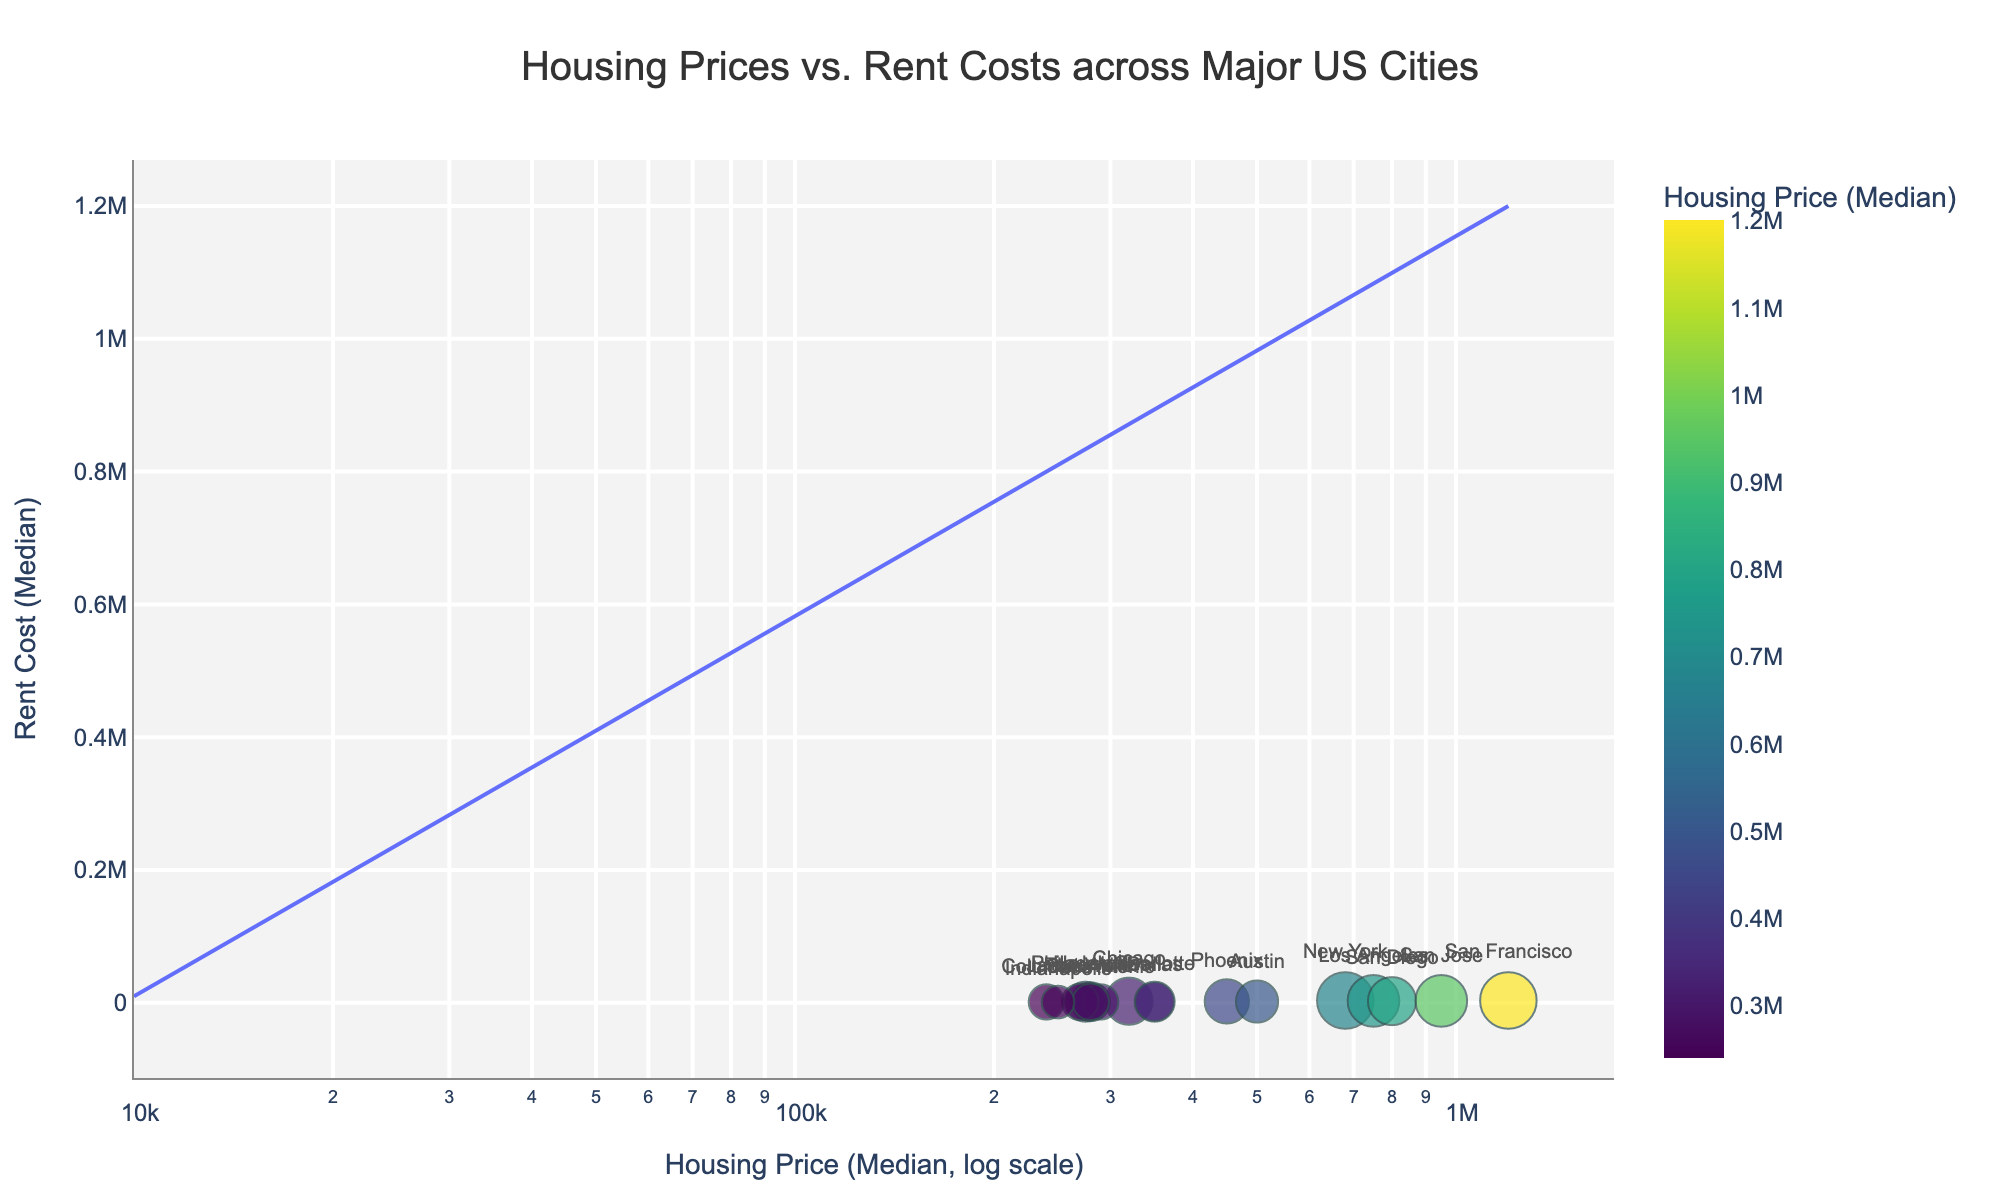what is the title of the scatter plot? The title of the scatter plot is typically located at the top center of the figure. In this case, it's given by the plot generation code.
Answer: Housing Prices vs. Rent Costs across Major US Cities how is the x-axis scaled? The x-axis in the plot uses a logarithmic scale, which is specified in the plot generation code. This is often used to manage a wide range of values more effectively.
Answer: Logarithmic scale which city has the highest housing price? The highest housing price can be identified as the data point farthest to the right on the x-axis.
Answer: San Francisco which city has the lowest rent cost? The lowest rent cost can be identified as the data point lowest on the y-axis.
Answer: Indianapolis how many cities have a housing price greater than $500,000? Count the data points that are located to the right of the $500,000 mark on the x-axis. Let's list them to count: Los Angeles, San Jose, San Francisco, (-)  ; New York, -.-. Further analysis indicates there are four cities.
Answer: 4 which city has a higher rent cost: Dallas or Phoenix? Compare the y-coordinates (Rent Cost) of the data points representing Dallas and Phoenix. Phoenix is higher.
Answer: Phoenix what is the approximate difference in rent cost between Chicago and Philadelphia? Find the data points for Chicago and Philadelphia and observe the difference in their y-coordinates (Rent Cost). Chicago is about $2500 - Philadelphia about $1800
Answer: $700 are there any cities where the rent cost is equal to the highest observed rent cost? The highest rent cost observed on the y-axis is $3600. Identify if any other cities share this value.
Answer: New York, San Francisco which city appears to have the most reasonable balance between housing price and rent cost? Cities closest to the diagonal reference line added in the plot indicate a balance between housing prices and rent costs. Identify the city closest to this line.
Answer: Phoenix which two cities share the same rent cost but have different housing prices? Look for data points with the same y-coordinate but different x-coordinates. Los Angeles and San Jose (both have $3000 rent cost).
Answer: Los Angeles and San Jose 